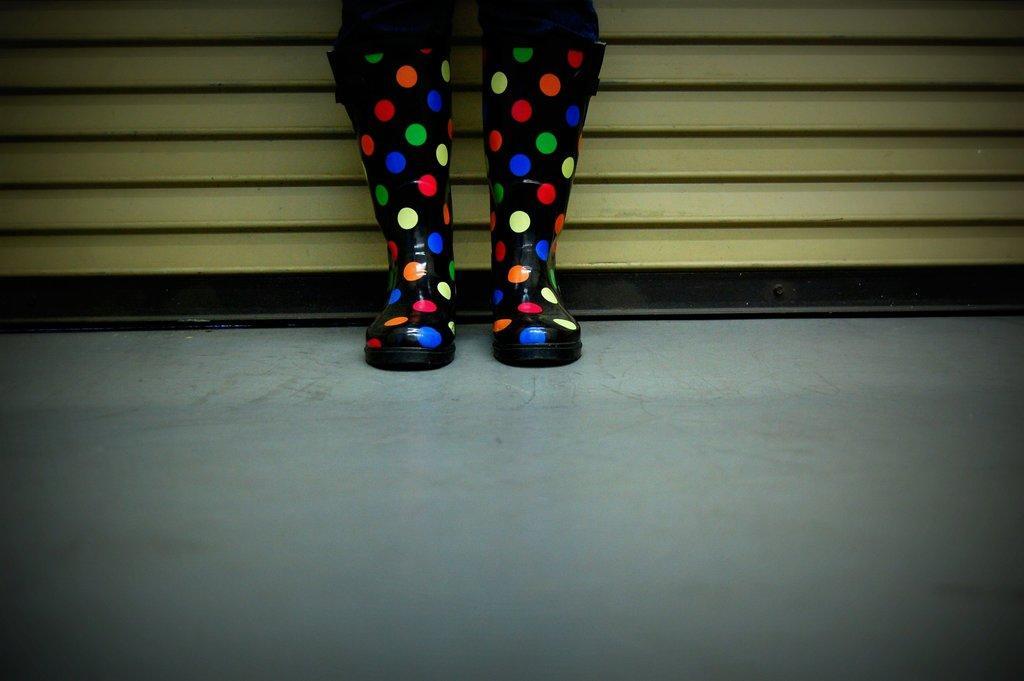In one or two sentences, can you explain what this image depicts? In this image, we can see colorful boots on the surface. Background we can see shutter. 